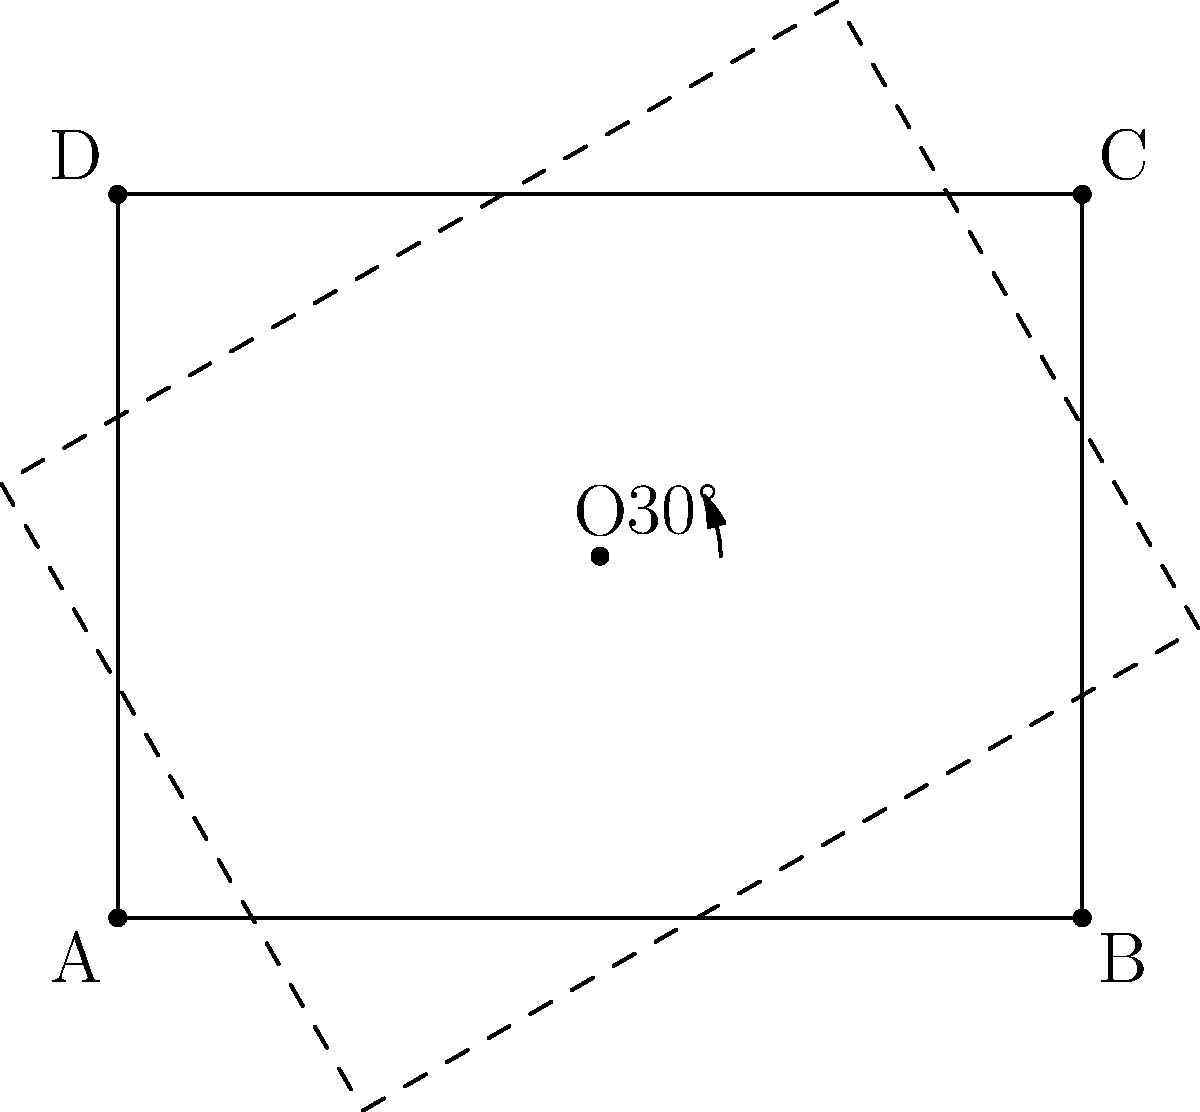A residential block is currently represented by a rectangle ABCD with dimensions 4 units by 3 units. To optimize land use, you propose rotating the block by 30° around its center point O. If the goal is to maximize the area of overlap between the original and rotated layouts, what percentage of the original block's area will remain unchanged after the rotation? To solve this problem, we'll follow these steps:

1) First, we need to understand that the area of overlap is the intersection of the original rectangle and its rotated version.

2) The shape of this intersection is complex and not easily calculable using elementary geometry.

3) However, we can use a theorem from analytic geometry: when a shape is rotated around its center, the area of overlap is always equal to the area of the original shape multiplied by $\cos \theta$, where $\theta$ is the angle of rotation.

4) In this case, $\theta = 30°$.

5) The area of overlap is thus:
   $A_{overlap} = A_{original} \cdot \cos 30°$

6) We know that $\cos 30° = \frac{\sqrt{3}}{2} \approx 0.866$

7) This means that 86.6% of the original area remains unchanged.

8) To express this as a percentage, we multiply by 100:
   $86.6\% \approx 86.6\%$

Therefore, approximately 86.6% of the original block's area will remain unchanged after the rotation.
Answer: 86.6% 